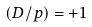Convert formula to latex. <formula><loc_0><loc_0><loc_500><loc_500>( D / p ) = + 1</formula> 